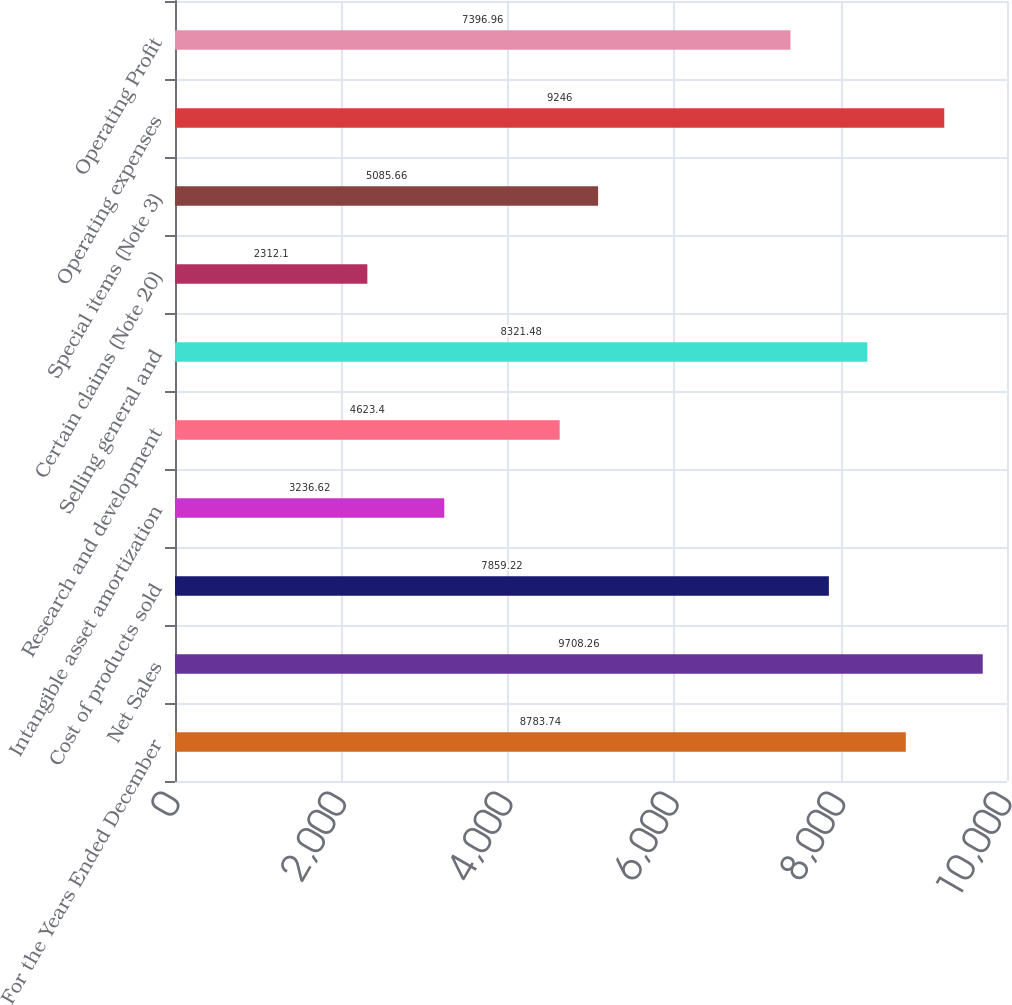<chart> <loc_0><loc_0><loc_500><loc_500><bar_chart><fcel>For the Years Ended December<fcel>Net Sales<fcel>Cost of products sold<fcel>Intangible asset amortization<fcel>Research and development<fcel>Selling general and<fcel>Certain claims (Note 20)<fcel>Special items (Note 3)<fcel>Operating expenses<fcel>Operating Profit<nl><fcel>8783.74<fcel>9708.26<fcel>7859.22<fcel>3236.62<fcel>4623.4<fcel>8321.48<fcel>2312.1<fcel>5085.66<fcel>9246<fcel>7396.96<nl></chart> 